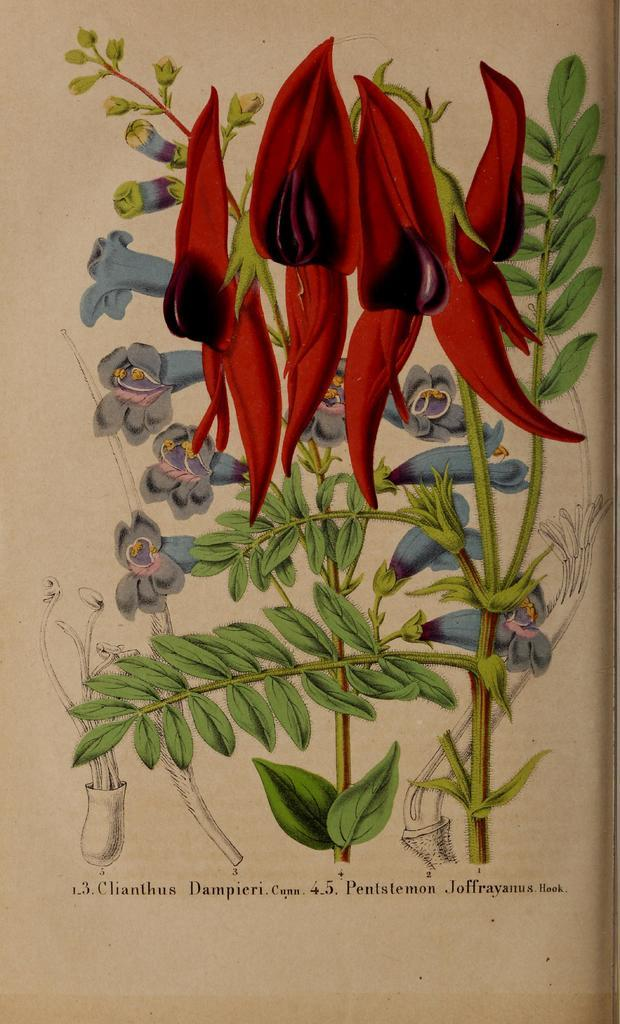What type of images can be seen in the picture? There are pictures of plants and flowers in the image. What is the medium for these images? The pictures are on a paper. What type of grain is visible in the image? There is no grain visible in the image; it features pictures of plants and flowers on a paper. How many grape-like are the flowers depicted in the image? The flowers in the image do not resemble grapes; they are depicted as flowers. 